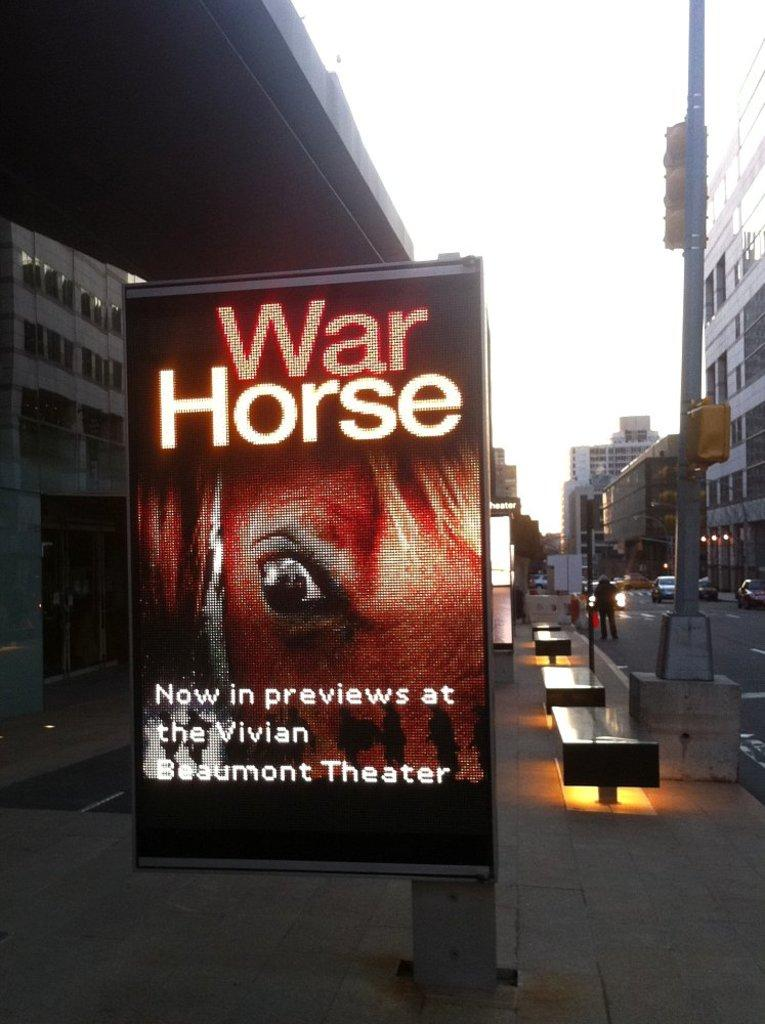Provide a one-sentence caption for the provided image. The War house is a brand new interesting show. 